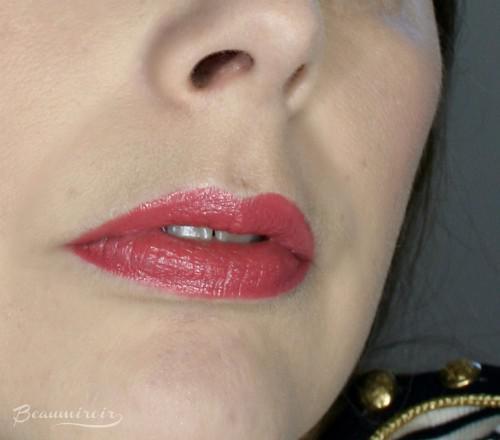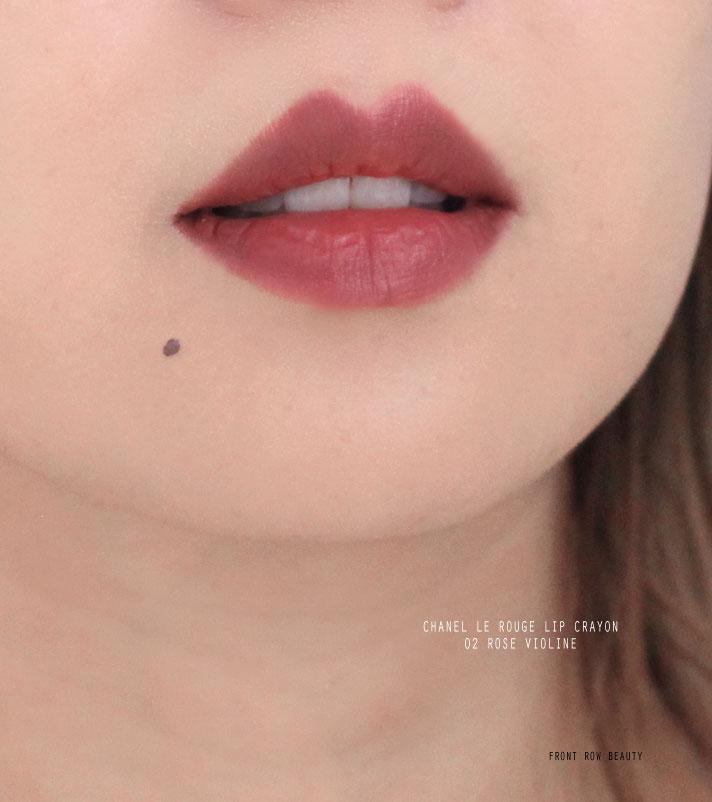The first image is the image on the left, the second image is the image on the right. Evaluate the accuracy of this statement regarding the images: "Both images show a brunette model with tinted, closed lips, and both models wear a pale top with a round neckline.". Is it true? Answer yes or no. No. 